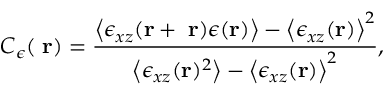Convert formula to latex. <formula><loc_0><loc_0><loc_500><loc_500>C _ { \epsilon } ( { \Delta r } ) = \frac { \left < \epsilon _ { x z } ( { r + \Delta r } ) \epsilon ( { r } ) \right > - \left < \epsilon _ { x z } ( { r } ) \right > ^ { 2 } } { \left < \epsilon _ { x z } ( { r } ) ^ { 2 } \right > - \left < \epsilon _ { x z } ( { r } ) \right > ^ { 2 } } ,</formula> 